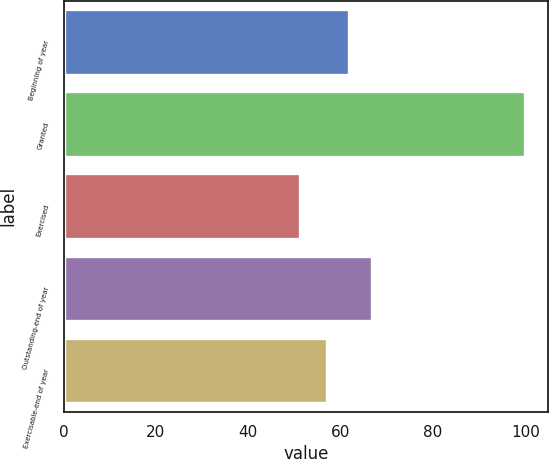<chart> <loc_0><loc_0><loc_500><loc_500><bar_chart><fcel>Beginning of year<fcel>Granted<fcel>Exercised<fcel>Outstanding-end of year<fcel>Exercisable-end of year<nl><fcel>61.84<fcel>99.92<fcel>51.26<fcel>66.71<fcel>56.97<nl></chart> 